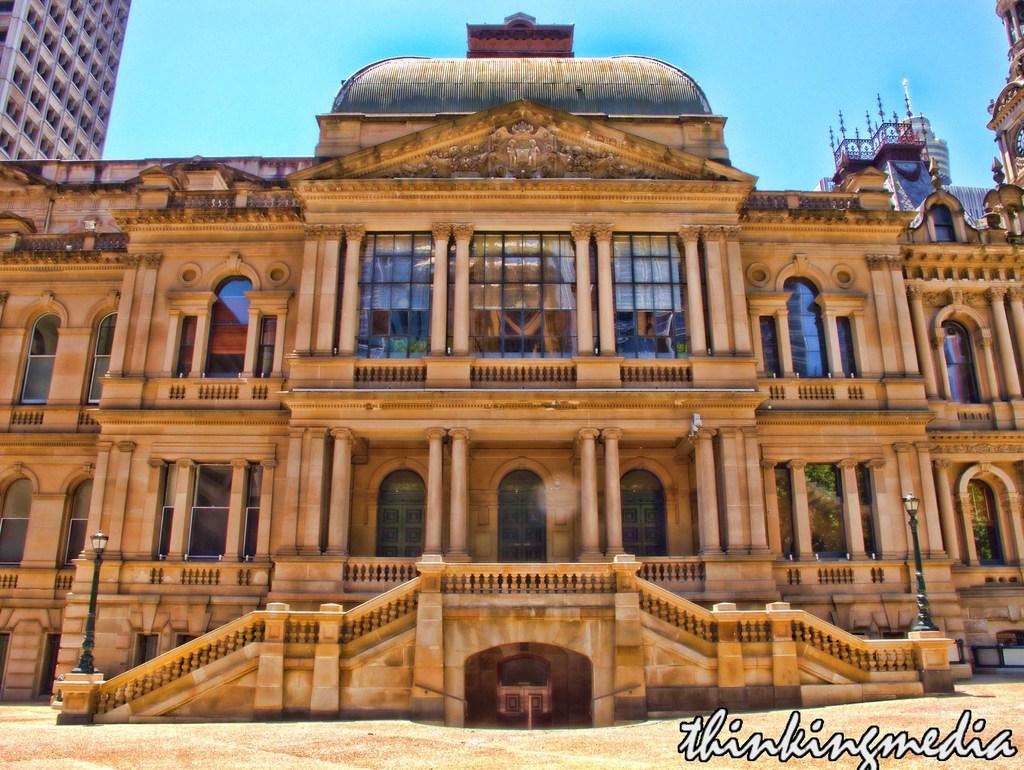<image>
Relay a brief, clear account of the picture shown. A large ornate building has the words thinkingmedia superimposed at the bottom. 